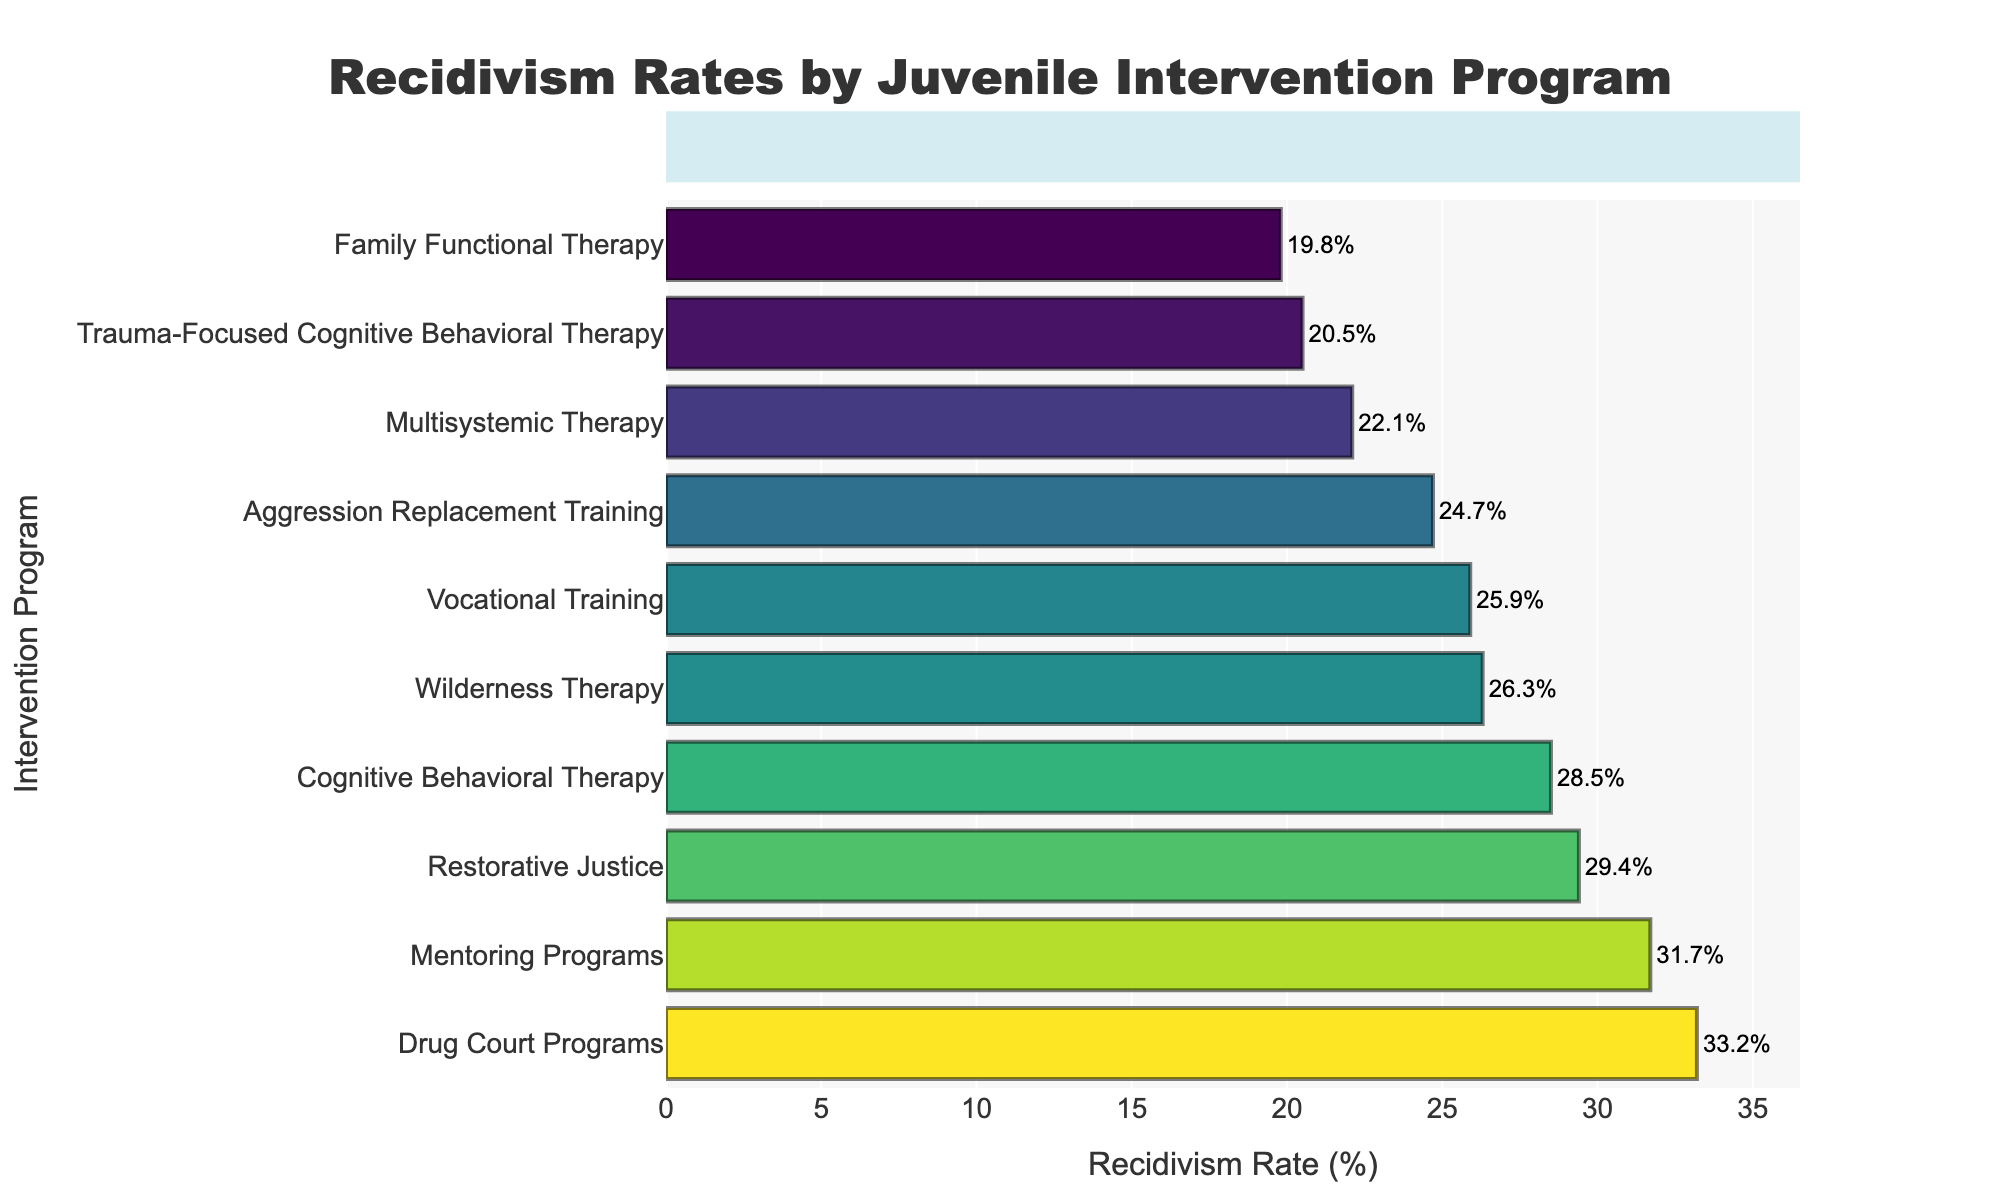What is the recidivism rate for Drug Court Programs? Look at the bar for Drug Court Programs, where the recidivism rate is labeled 33.2%.
Answer: 33.2% Which intervention program has the lowest recidivism rate? Identify the bar with the smallest value. Family Functional Therapy has the lowest rate of 19.8%.
Answer: Family Functional Therapy Which program has a higher recidivism rate: Cognitive Behavioral Therapy or Multisystemic Therapy? Check the recidivism rates of both programs. Cognitive Behavioral Therapy has a rate of 28.5%, and Multisystemic Therapy has a rate of 22.1%.
Answer: Cognitive Behavioral Therapy How much higher is the recidivism rate for Mentoring Programs compared to Trauma-Focused Cognitive Behavioral Therapy? Subtract the recidivism rate of Trauma-Focused Cognitive Behavioral Therapy (20.5%) from that of Mentoring Programs (31.7%) to get the difference.
Answer: 11.2% What is the average recidivism rate of the top three programs with the highest rates? The top three programs with the highest rates are Drug Court Programs (33.2%), Mentoring Programs (31.7%), and Restorative Justice (29.4%). Average = (33.2% + 31.7% + 29.4%) / 3 ≈ 31.43%
Answer: 31.43% Of the given programs, how many have a recidivism rate lower than 25%? Count the number of bars where the recidivism rate is less than 25%. Programs are: Multisystemic Therapy (22.1%), Family Functional Therapy (19.8%), Trauma-Focused Cognitive Behavioral Therapy (20.5%), and Aggression Replacement Training (24.7%).
Answer: 4 Which intervention program(s) have a recidivism rate closest to 30%? Identify the bars with recidivism rates close to 30%. Restorative Justice has a rate of 29.4%, and Cognitive Behavioral Therapy has a rate of 28.5%.
Answer: Restorative Justice and Cognitive Behavioral Therapy What is the difference in recidivism rate between the highest and the lowest rate programs? Subtract the lowest recidivism rate (Family Functional Therapy, 19.8%) from the highest recidivism rate (Drug Court Programs, 33.2%).
Answer: 13.4% Is the height of the bar representing Wilderness Therapy visually greater than that of Vocational Training? Compare the bar heights. The Recidivism Rate for Wilderness Therapy (26.3%) is slightly higher than that for Vocational Training (25.9%).
Answer: Yes What is the average recidivism rate of all the intervention programs? Sum the recidivism rates of all programs and divide by the number of programs: (28.5% + 22.1% + 31.7% + 25.9% + 19.8% + 33.2% + 29.4% + 26.3% + 24.7% + 20.5%) / 10 ≈ 26.21%
Answer: 26.21% 